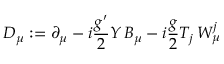Convert formula to latex. <formula><loc_0><loc_0><loc_500><loc_500>D _ { \mu } \colon = \partial _ { \mu } - i { \frac { g ^ { \prime } } { 2 } } Y \, B _ { \mu } - i { \frac { g } { 2 } } T _ { j } \, W _ { \mu } ^ { j }</formula> 